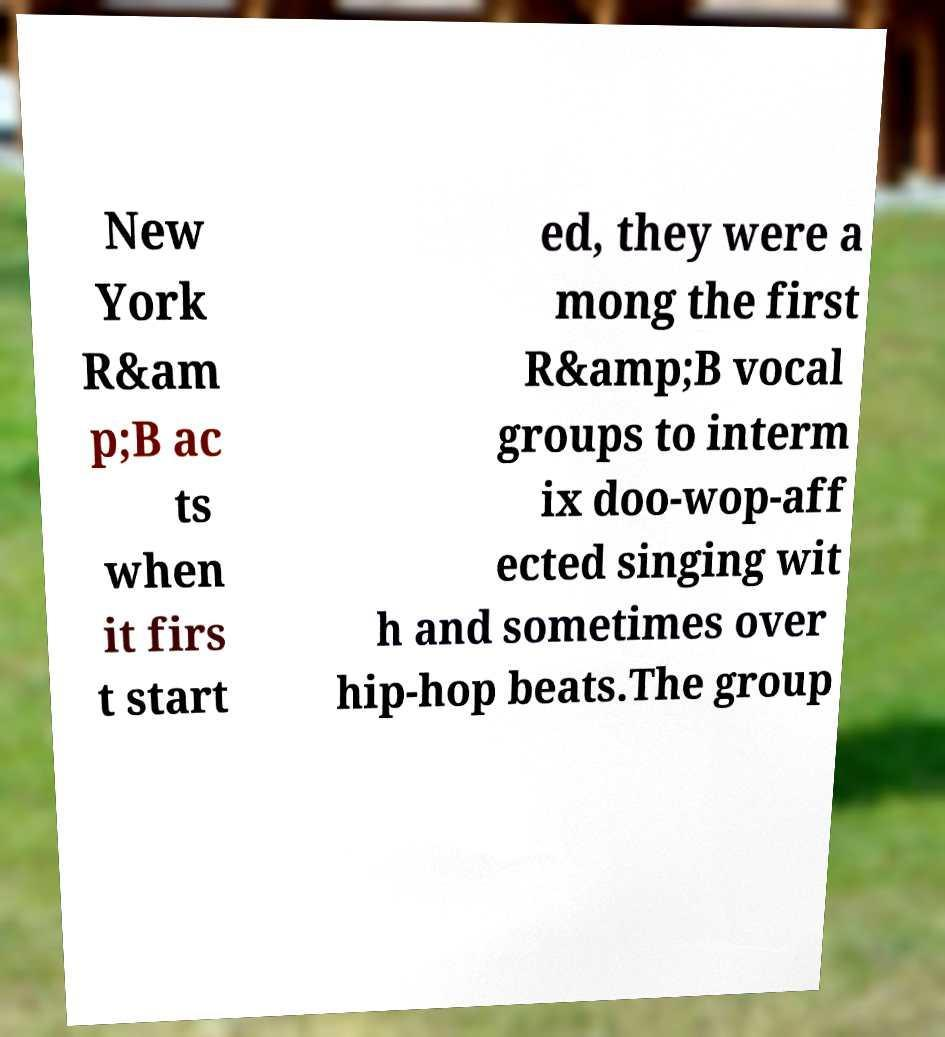Please read and relay the text visible in this image. What does it say? New York R&am p;B ac ts when it firs t start ed, they were a mong the first R&amp;B vocal groups to interm ix doo-wop-aff ected singing wit h and sometimes over hip-hop beats.The group 